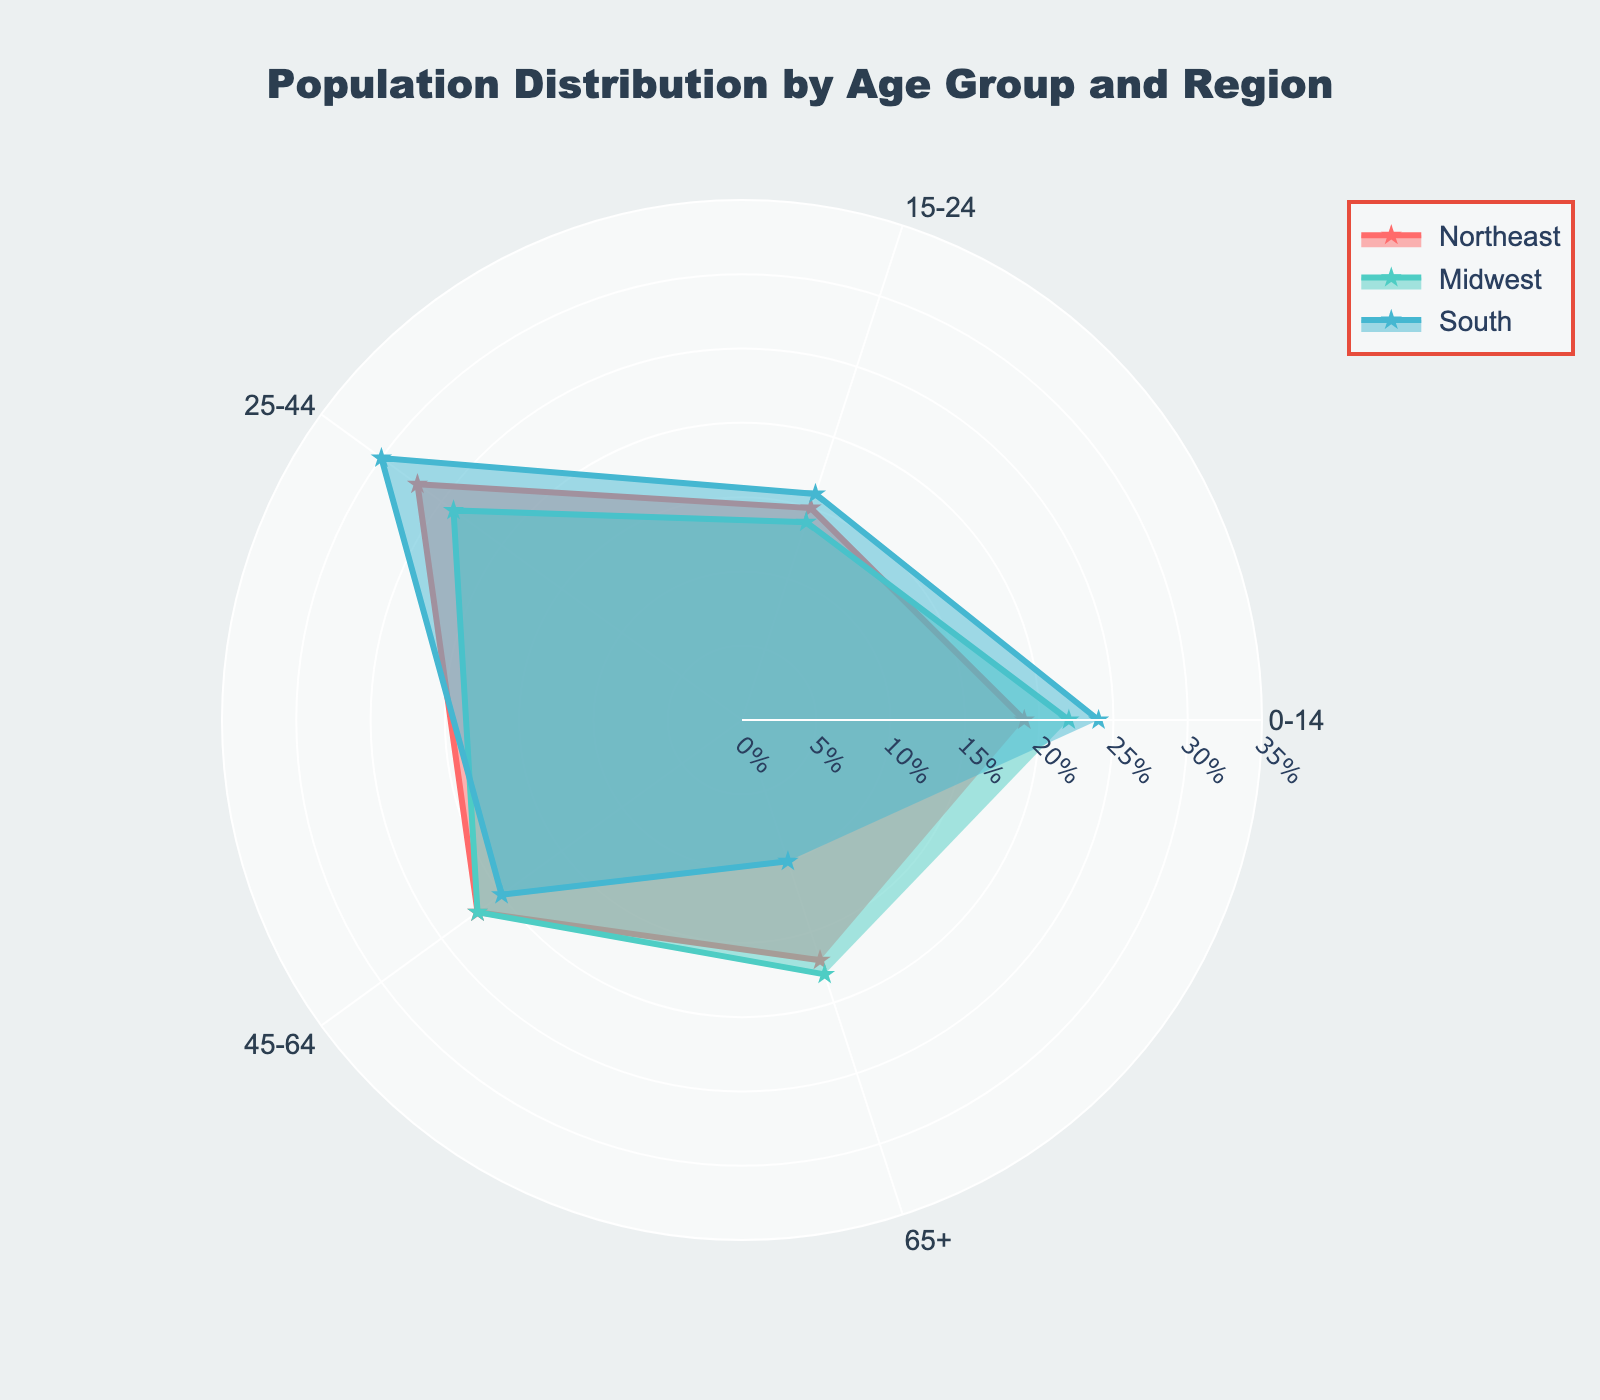Which age group has the lowest population percentage in the South? From the radar chart, identify the point representing the South region and find the age group where the corresponding value is the smallest
Answer: 65+ What is the average population percentage for the Midwest across all age groups? Sum the population percentages of all age groups in the Midwest and then divide by the number of age groups, i.e., (22% + 14% + 24% + 22% + 18%) / 5
Answer: 20% In which region is the population percentage of the 0-14 age group the highest? Compare the values of the 0-14 age group for Northeast, Midwest, South, and West. The highest value determines the region
Answer: South By how much does the population percentage of the 25-44 age group differ between the Northeast and the Midwest? Subtract the population percentage of the Midwest's 25-44 age group from that of the Northeast for the same age group, i.e., 27% - 24%
Answer: 3% Which region shows a higher percentage for the 45-64 age group, Northeast or South? Compare the values for the 45-64 age group between Northeast and South. The higher value indicates the respective region
Answer: Northeast Is the 65+ age group population percentage higher in the West or the Northeast? Compare the values for the 65+ age group between West and Northeast. The higher value indicates the respective region
Answer: Northeast What is the difference in the population percentage between the youngest (0-14) and the oldest (65+) age groups in the Midwest? Subtract the population percentage of the 65+ age group from that of the 0-14 age group in the Midwest, i.e., 22% - 18%
Answer: 4% Determine which region's radar chart line area is larger between the Midwest and the South Compare the areas covered by the radar chart lines for the Midwest and South. The region with the larger area has a higher overall population percentage across all age groups
Answer: South Based on the radar chart, which region shows a consistent population percentage across all age groups? Identify the region whose radar chart line is more evenly distributed across the categories (age groups). Consistency suggests less variability among age group percentages
Answer: Northeast 